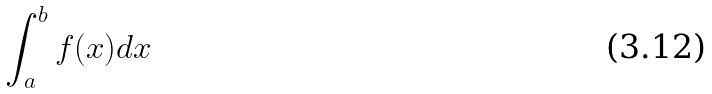<formula> <loc_0><loc_0><loc_500><loc_500>\int _ { a } ^ { b } f ( x ) d x</formula> 